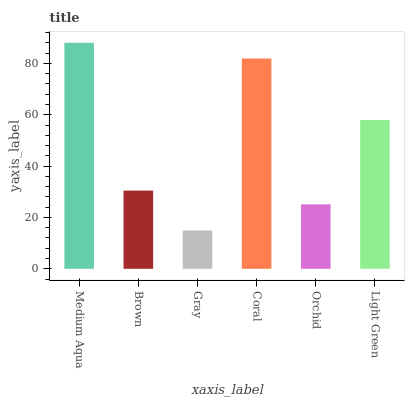Is Gray the minimum?
Answer yes or no. Yes. Is Medium Aqua the maximum?
Answer yes or no. Yes. Is Brown the minimum?
Answer yes or no. No. Is Brown the maximum?
Answer yes or no. No. Is Medium Aqua greater than Brown?
Answer yes or no. Yes. Is Brown less than Medium Aqua?
Answer yes or no. Yes. Is Brown greater than Medium Aqua?
Answer yes or no. No. Is Medium Aqua less than Brown?
Answer yes or no. No. Is Light Green the high median?
Answer yes or no. Yes. Is Brown the low median?
Answer yes or no. Yes. Is Orchid the high median?
Answer yes or no. No. Is Coral the low median?
Answer yes or no. No. 